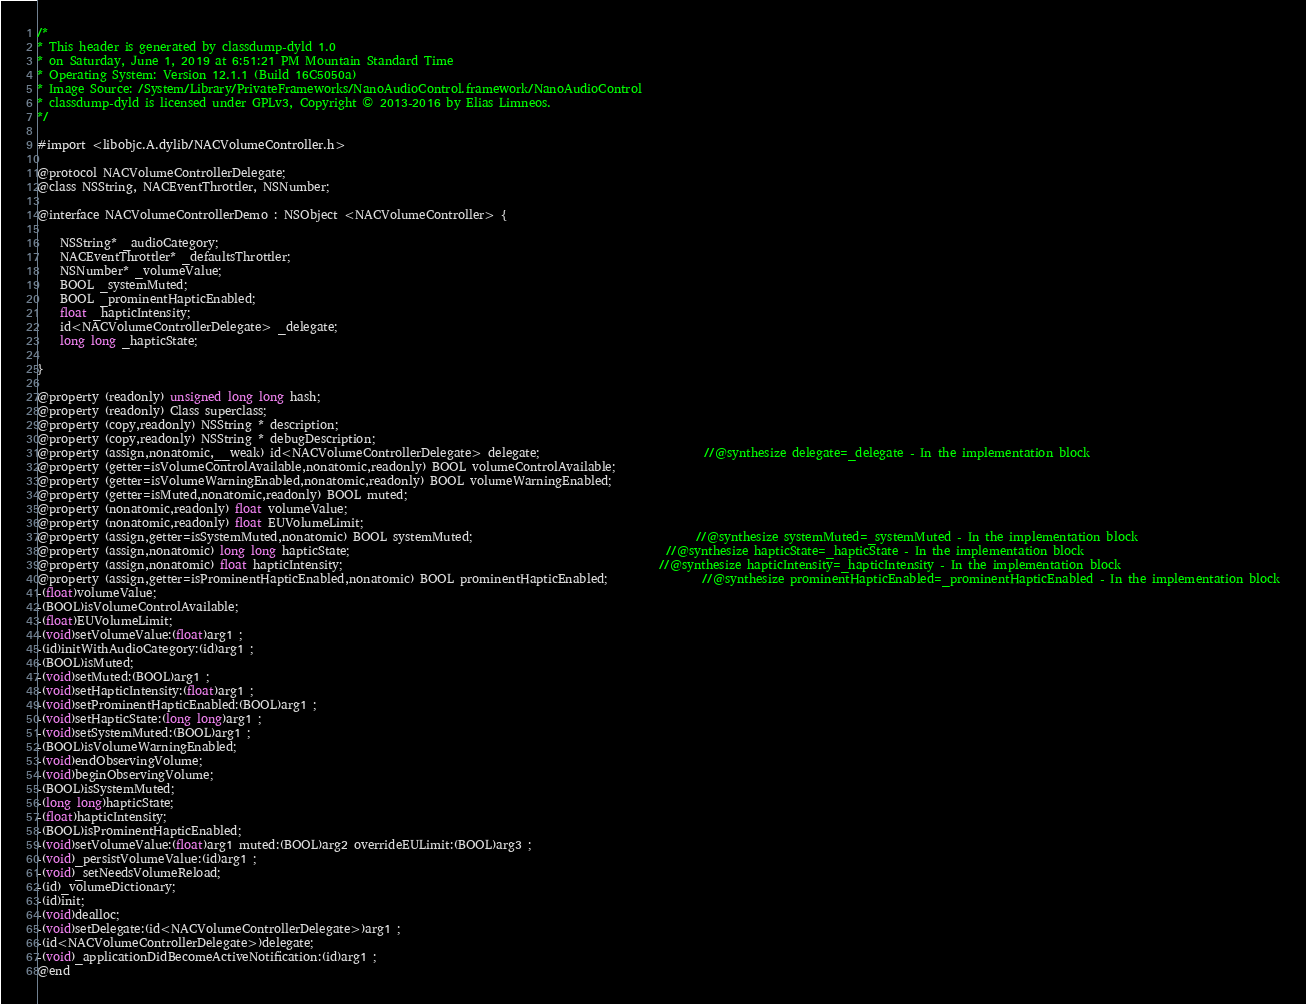Convert code to text. <code><loc_0><loc_0><loc_500><loc_500><_C_>/*
* This header is generated by classdump-dyld 1.0
* on Saturday, June 1, 2019 at 6:51:21 PM Mountain Standard Time
* Operating System: Version 12.1.1 (Build 16C5050a)
* Image Source: /System/Library/PrivateFrameworks/NanoAudioControl.framework/NanoAudioControl
* classdump-dyld is licensed under GPLv3, Copyright © 2013-2016 by Elias Limneos.
*/

#import <libobjc.A.dylib/NACVolumeController.h>

@protocol NACVolumeControllerDelegate;
@class NSString, NACEventThrottler, NSNumber;

@interface NACVolumeControllerDemo : NSObject <NACVolumeController> {

	NSString* _audioCategory;
	NACEventThrottler* _defaultsThrottler;
	NSNumber* _volumeValue;
	BOOL _systemMuted;
	BOOL _prominentHapticEnabled;
	float _hapticIntensity;
	id<NACVolumeControllerDelegate> _delegate;
	long long _hapticState;

}

@property (readonly) unsigned long long hash; 
@property (readonly) Class superclass; 
@property (copy,readonly) NSString * description; 
@property (copy,readonly) NSString * debugDescription; 
@property (assign,nonatomic,__weak) id<NACVolumeControllerDelegate> delegate;                            //@synthesize delegate=_delegate - In the implementation block
@property (getter=isVolumeControlAvailable,nonatomic,readonly) BOOL volumeControlAvailable; 
@property (getter=isVolumeWarningEnabled,nonatomic,readonly) BOOL volumeWarningEnabled; 
@property (getter=isMuted,nonatomic,readonly) BOOL muted; 
@property (nonatomic,readonly) float volumeValue; 
@property (nonatomic,readonly) float EUVolumeLimit; 
@property (assign,getter=isSystemMuted,nonatomic) BOOL systemMuted;                                      //@synthesize systemMuted=_systemMuted - In the implementation block
@property (assign,nonatomic) long long hapticState;                                                      //@synthesize hapticState=_hapticState - In the implementation block
@property (assign,nonatomic) float hapticIntensity;                                                      //@synthesize hapticIntensity=_hapticIntensity - In the implementation block
@property (assign,getter=isProminentHapticEnabled,nonatomic) BOOL prominentHapticEnabled;                //@synthesize prominentHapticEnabled=_prominentHapticEnabled - In the implementation block
-(float)volumeValue;
-(BOOL)isVolumeControlAvailable;
-(float)EUVolumeLimit;
-(void)setVolumeValue:(float)arg1 ;
-(id)initWithAudioCategory:(id)arg1 ;
-(BOOL)isMuted;
-(void)setMuted:(BOOL)arg1 ;
-(void)setHapticIntensity:(float)arg1 ;
-(void)setProminentHapticEnabled:(BOOL)arg1 ;
-(void)setHapticState:(long long)arg1 ;
-(void)setSystemMuted:(BOOL)arg1 ;
-(BOOL)isVolumeWarningEnabled;
-(void)endObservingVolume;
-(void)beginObservingVolume;
-(BOOL)isSystemMuted;
-(long long)hapticState;
-(float)hapticIntensity;
-(BOOL)isProminentHapticEnabled;
-(void)setVolumeValue:(float)arg1 muted:(BOOL)arg2 overrideEULimit:(BOOL)arg3 ;
-(void)_persistVolumeValue:(id)arg1 ;
-(void)_setNeedsVolumeReload;
-(id)_volumeDictionary;
-(id)init;
-(void)dealloc;
-(void)setDelegate:(id<NACVolumeControllerDelegate>)arg1 ;
-(id<NACVolumeControllerDelegate>)delegate;
-(void)_applicationDidBecomeActiveNotification:(id)arg1 ;
@end

</code> 